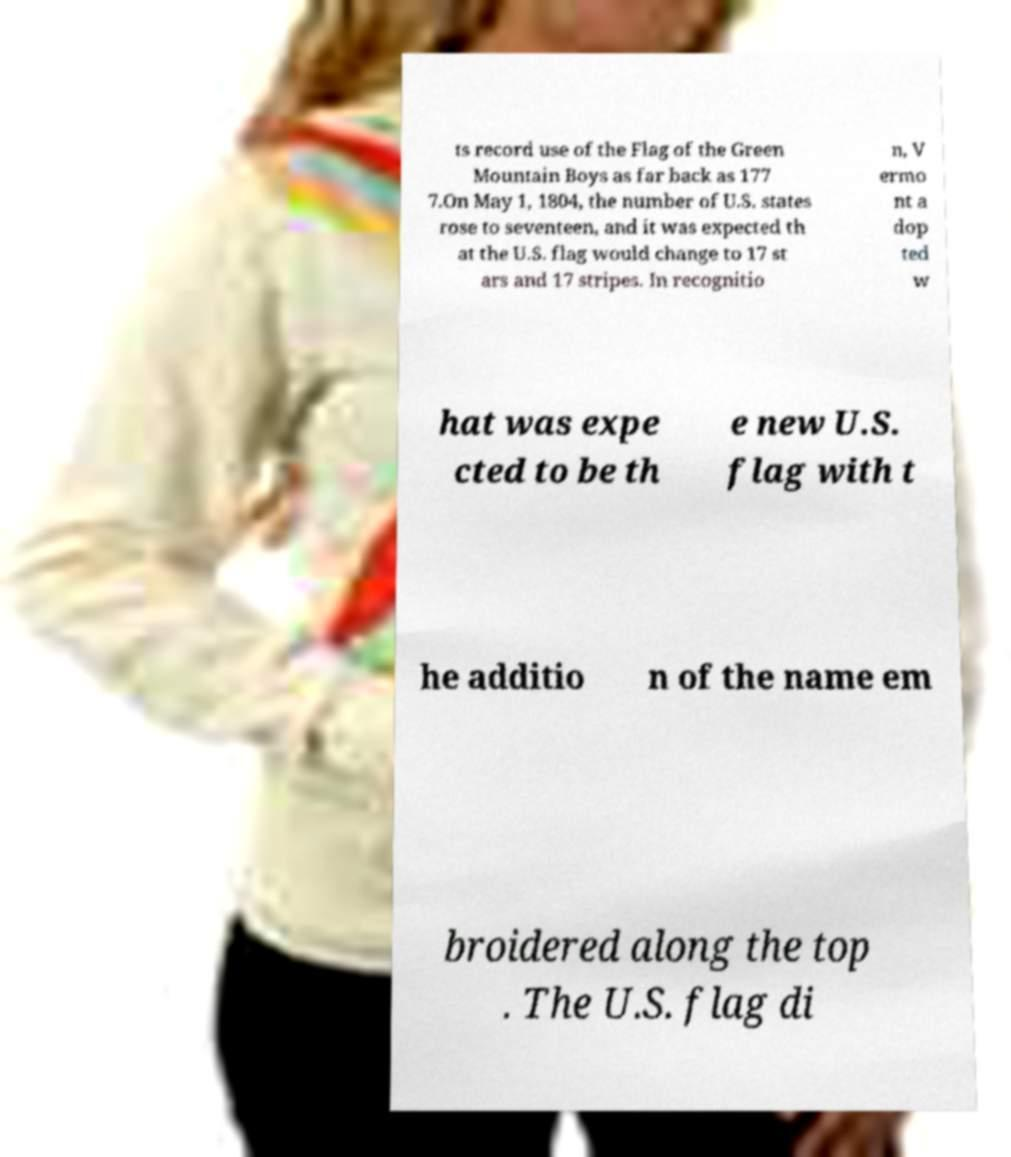For documentation purposes, I need the text within this image transcribed. Could you provide that? ts record use of the Flag of the Green Mountain Boys as far back as 177 7.On May 1, 1804, the number of U.S. states rose to seventeen, and it was expected th at the U.S. flag would change to 17 st ars and 17 stripes. In recognitio n, V ermo nt a dop ted w hat was expe cted to be th e new U.S. flag with t he additio n of the name em broidered along the top . The U.S. flag di 